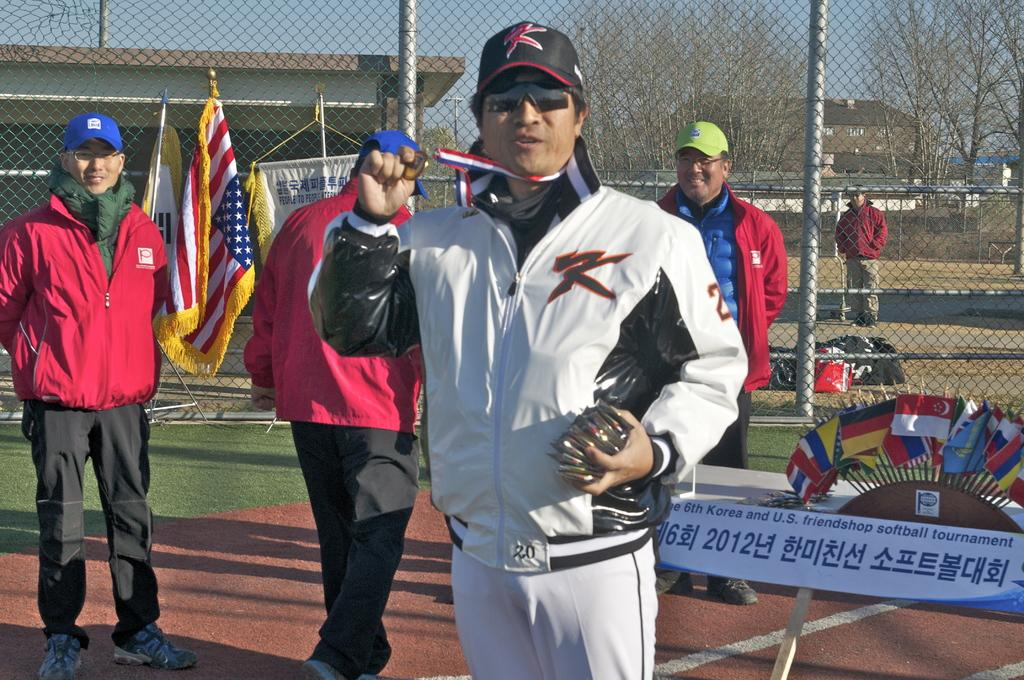<image>
Write a terse but informative summary of the picture. A man in a jacket and hat that say K on them shows off his award. 